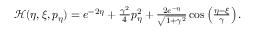<formula> <loc_0><loc_0><loc_500><loc_500>\begin{array} { r } { \mathcal { H } ( \eta , \xi , p _ { \eta } ) = e ^ { - 2 \eta } + \frac { \gamma ^ { 2 } } { 4 } p _ { \eta } ^ { 2 } + \frac { 2 e ^ { - \eta } } { \sqrt { 1 + \gamma ^ { 2 } } } \cos \left ( \frac { \eta - \xi } { \gamma } \right ) . } \end{array}</formula> 